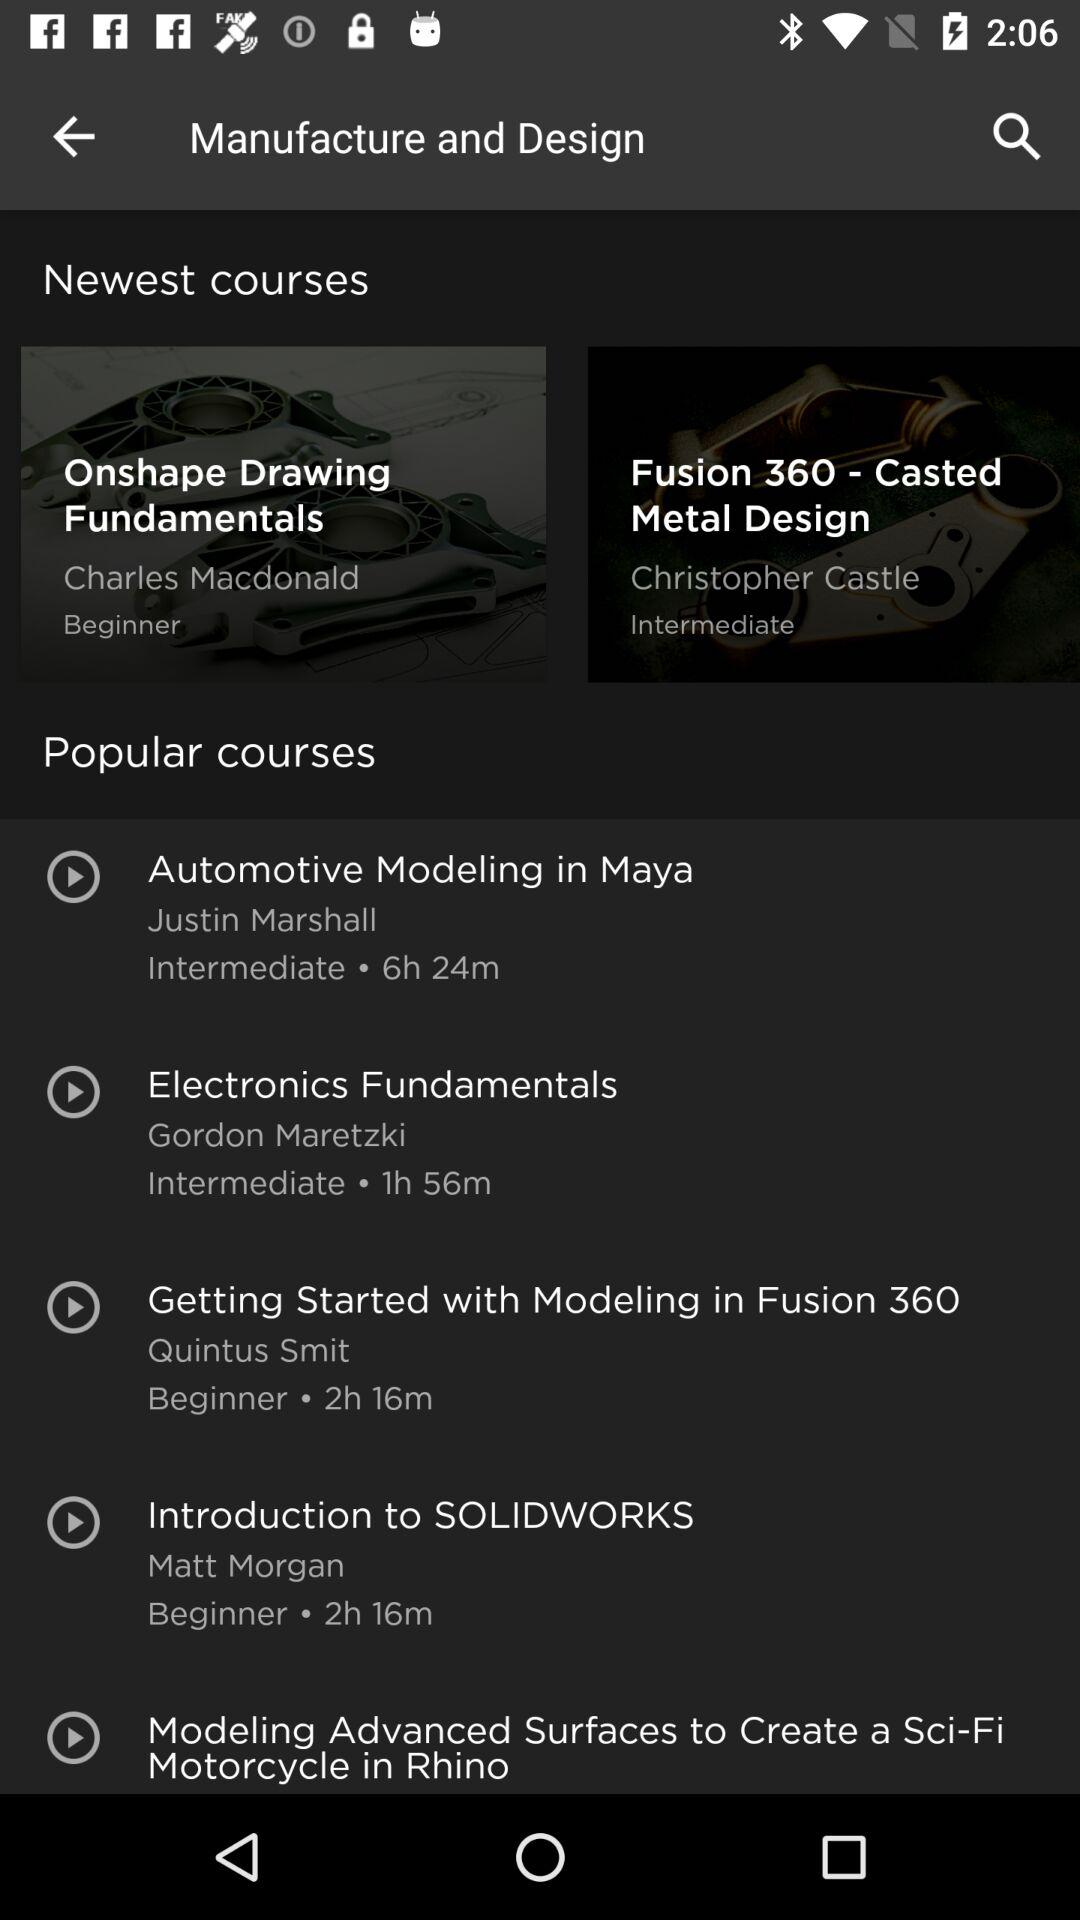Which is the level of "Electronics Fundamentals"? The level is intermediate. 